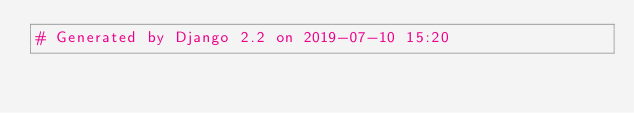<code> <loc_0><loc_0><loc_500><loc_500><_Python_># Generated by Django 2.2 on 2019-07-10 15:20
</code> 